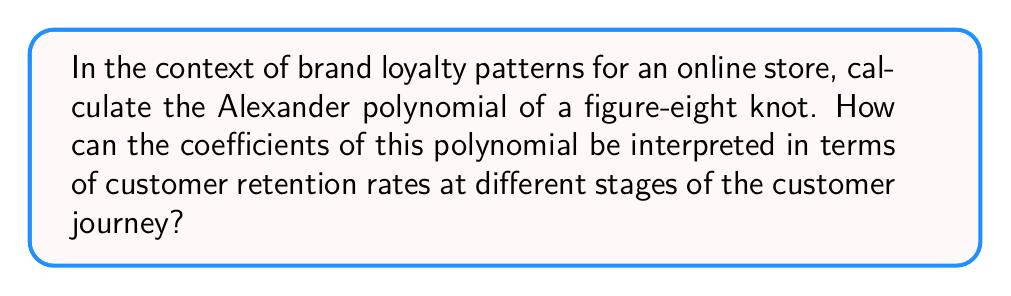Could you help me with this problem? To compute the Alexander polynomial for a figure-eight knot and interpret it in terms of brand loyalty patterns, we'll follow these steps:

1. First, we need to draw the figure-eight knot diagram:

[asy]
import geometry;

path p = (0,0)..(-1,1)..(0,2)..(1,1)..(0,0)..(1,-1)..(0,-2)..(-1,-1)..cycle;
draw(p, linewidth(1));
draw((0.3,0.3)--(0.7,-0.3), linewidth(1));
draw((0.3,-0.3)--(0.7,0.3), linewidth(1));
label("a", (0,1), E);
label("b", (0,-1), E);
label("c", (-0.5,0), W);
label("d", (0.5,0), E);
[/asy]

2. Assign variables to the arcs: a, b, c, and d as shown in the diagram.

3. Write down the Alexander-Conway skein relations for each crossing:

$$t^{-1/2}a - t^{1/2}c = 0$$
$$t^{-1/2}b - t^{1/2}d = 0$$
$$t^{-1/2}c - t^{1/2}b = 0$$
$$t^{-1/2}d - t^{1/2}a = 0$$

4. Eliminate variables to obtain the Alexander polynomial:

Substitute $c = t^{1/2}a$ and $d = t^{1/2}b$ from the first two equations into the last two:

$$t^{-1/2}(t^{1/2}a) - t^{1/2}b = 0$$
$$t^{-1/2}(t^{1/2}b) - t^{1/2}a = 0$$

Simplify:

$$a - t^{1/2}b = 0$$
$$b - t^{1/2}a = 0$$

From the first equation: $a = t^{1/2}b$
Substitute into the second equation:

$$b - t^{1/2}(t^{1/2}b) = 0$$
$$b - tb = 0$$
$$(1-t)b = 0$$

5. The Alexander polynomial is therefore:

$$\Delta(t) = 1 - t + t^2 - t^3$$

6. Interpretation in terms of brand loyalty:
   - Coefficient 1: Initial customer acquisition
   - Coefficient -1: First-time customer churn
   - Coefficient 1: Returning customer rate
   - Coefficient -1: Long-term customer attrition

The alternating signs suggest a cyclical pattern in customer behavior, which could be interpreted as follows:
- Positive coefficients represent successful retention or acquisition stages
- Negative coefficients represent stages where customers are more likely to churn
- The polynomial's degree (3) suggests four distinct stages in the customer journey

This pattern indicates that the online store should focus on improving retention strategies at the second and fourth stages of the customer journey to counteract the negative trends and enhance overall brand loyalty.
Answer: $\Delta(t) = 1 - t + t^2 - t^3$ 